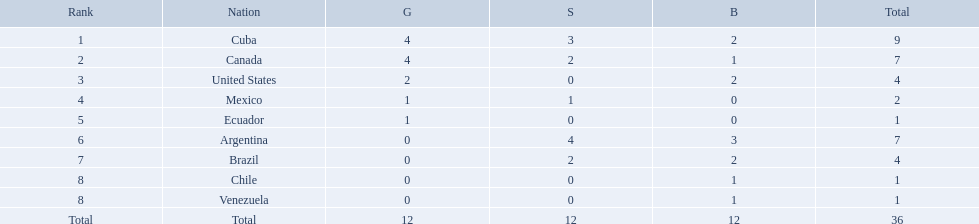Which nations competed in the 2011 pan american games? Cuba, Canada, United States, Mexico, Ecuador, Argentina, Brazil, Chile, Venezuela. Of these nations which ones won gold? Cuba, Canada, United States, Mexico, Ecuador. Which nation of the ones that won gold did not win silver? United States. What were all of the nations involved in the canoeing at the 2011 pan american games? Cuba, Canada, United States, Mexico, Ecuador, Argentina, Brazil, Chile, Venezuela, Total. Of these, which had a numbered rank? Cuba, Canada, United States, Mexico, Ecuador, Argentina, Brazil, Chile, Venezuela. From these, which had the highest number of bronze? Argentina. Which countries won medals at the 2011 pan american games for the canoeing event? Cuba, Canada, United States, Mexico, Ecuador, Argentina, Brazil, Chile, Venezuela. Which of these countries won bronze medals? Cuba, Canada, United States, Argentina, Brazil, Chile, Venezuela. Of these countries, which won the most bronze medals? Argentina. 